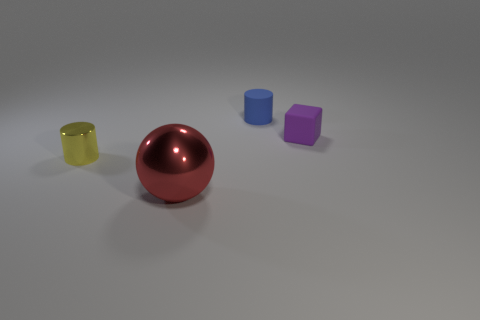How many other yellow metal things have the same shape as the big metal thing?
Make the answer very short. 0. What number of metallic cylinders are there?
Give a very brief answer. 1. What color is the metallic thing that is in front of the yellow metal thing?
Provide a short and direct response. Red. There is a small cylinder behind the cylinder that is to the left of the large shiny sphere; what color is it?
Your response must be concise. Blue. There is another cylinder that is the same size as the rubber cylinder; what is its color?
Provide a short and direct response. Yellow. How many tiny things are both on the left side of the purple cube and on the right side of the large sphere?
Provide a short and direct response. 1. What is the small object that is left of the rubber cube and in front of the tiny blue matte object made of?
Provide a short and direct response. Metal. Is the number of shiny balls that are in front of the big metallic thing less than the number of tiny matte blocks behind the small metallic cylinder?
Provide a succinct answer. Yes. What size is the other thing that is the same material as the tiny blue thing?
Your answer should be very brief. Small. Are there any other things that have the same color as the metallic ball?
Keep it short and to the point. No. 